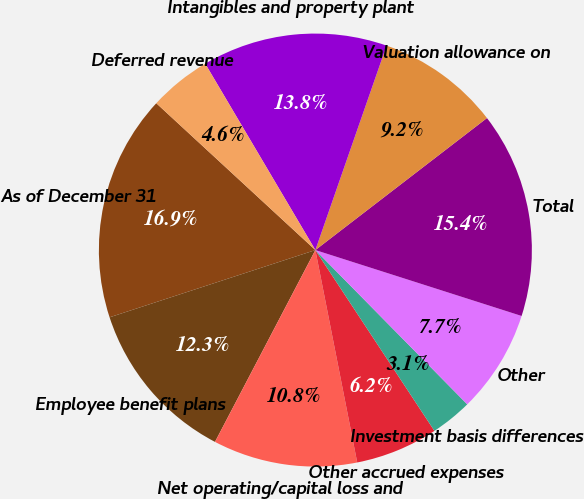Convert chart to OTSL. <chart><loc_0><loc_0><loc_500><loc_500><pie_chart><fcel>As of December 31<fcel>Employee benefit plans<fcel>Net operating/capital loss and<fcel>Other accrued expenses<fcel>Investment basis differences<fcel>Other<fcel>Total<fcel>Valuation allowance on<fcel>Intangibles and property plant<fcel>Deferred revenue<nl><fcel>16.89%<fcel>12.3%<fcel>10.77%<fcel>6.17%<fcel>3.11%<fcel>7.7%<fcel>15.36%<fcel>9.23%<fcel>13.83%<fcel>4.64%<nl></chart> 